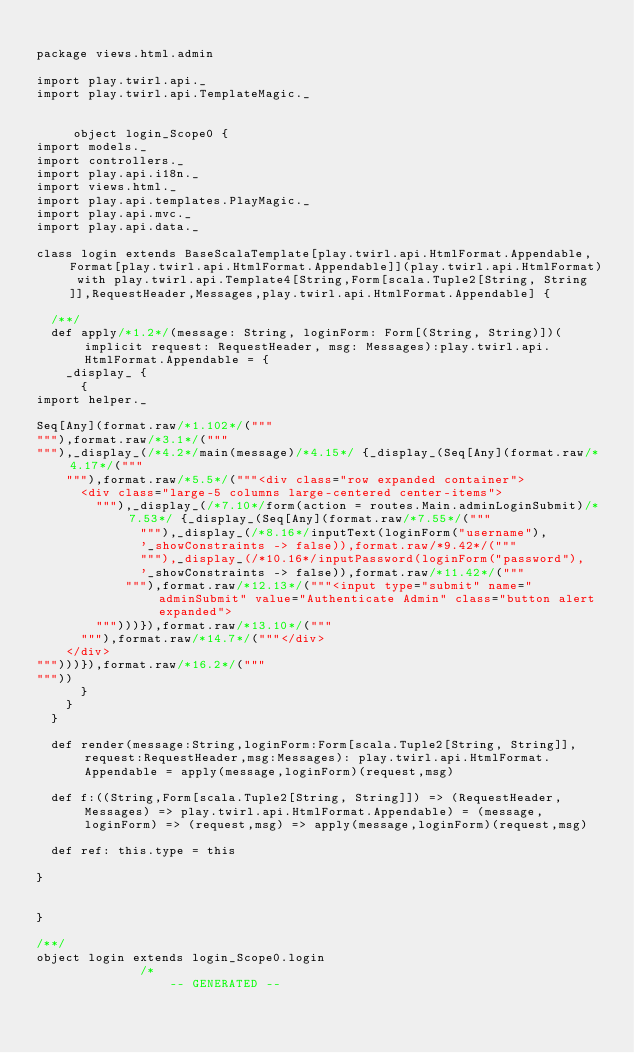Convert code to text. <code><loc_0><loc_0><loc_500><loc_500><_Scala_>
package views.html.admin

import play.twirl.api._
import play.twirl.api.TemplateMagic._


     object login_Scope0 {
import models._
import controllers._
import play.api.i18n._
import views.html._
import play.api.templates.PlayMagic._
import play.api.mvc._
import play.api.data._

class login extends BaseScalaTemplate[play.twirl.api.HtmlFormat.Appendable,Format[play.twirl.api.HtmlFormat.Appendable]](play.twirl.api.HtmlFormat) with play.twirl.api.Template4[String,Form[scala.Tuple2[String, String]],RequestHeader,Messages,play.twirl.api.HtmlFormat.Appendable] {

  /**/
  def apply/*1.2*/(message: String, loginForm: Form[(String, String)])(implicit request: RequestHeader, msg: Messages):play.twirl.api.HtmlFormat.Appendable = {
    _display_ {
      {
import helper._

Seq[Any](format.raw/*1.102*/("""
"""),format.raw/*3.1*/("""
"""),_display_(/*4.2*/main(message)/*4.15*/ {_display_(Seq[Any](format.raw/*4.17*/("""
    """),format.raw/*5.5*/("""<div class="row expanded container">
      <div class="large-5 columns large-centered center-items">
        """),_display_(/*7.10*/form(action = routes.Main.adminLoginSubmit)/*7.53*/ {_display_(Seq[Any](format.raw/*7.55*/("""
              """),_display_(/*8.16*/inputText(loginForm("username"),
              '_showConstraints -> false)),format.raw/*9.42*/("""
              """),_display_(/*10.16*/inputPassword(loginForm("password"),
              '_showConstraints -> false)),format.raw/*11.42*/("""
            """),format.raw/*12.13*/("""<input type="submit" name="adminSubmit" value="Authenticate Admin" class="button alert expanded">
        """)))}),format.raw/*13.10*/("""
      """),format.raw/*14.7*/("""</div>
    </div>
""")))}),format.raw/*16.2*/("""
"""))
      }
    }
  }

  def render(message:String,loginForm:Form[scala.Tuple2[String, String]],request:RequestHeader,msg:Messages): play.twirl.api.HtmlFormat.Appendable = apply(message,loginForm)(request,msg)

  def f:((String,Form[scala.Tuple2[String, String]]) => (RequestHeader,Messages) => play.twirl.api.HtmlFormat.Appendable) = (message,loginForm) => (request,msg) => apply(message,loginForm)(request,msg)

  def ref: this.type = this

}


}

/**/
object login extends login_Scope0.login
              /*
                  -- GENERATED --</code> 